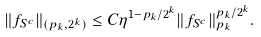<formula> <loc_0><loc_0><loc_500><loc_500>\| f _ { S ^ { c } } \| _ { ( p _ { k } , 2 ^ { k } ) } \leq C \eta ^ { 1 - p _ { k } / 2 ^ { k } } \| f _ { S ^ { c } } \| _ { p _ { k } } ^ { p _ { k } / 2 ^ { k } } .</formula> 